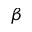<formula> <loc_0><loc_0><loc_500><loc_500>\beta</formula> 